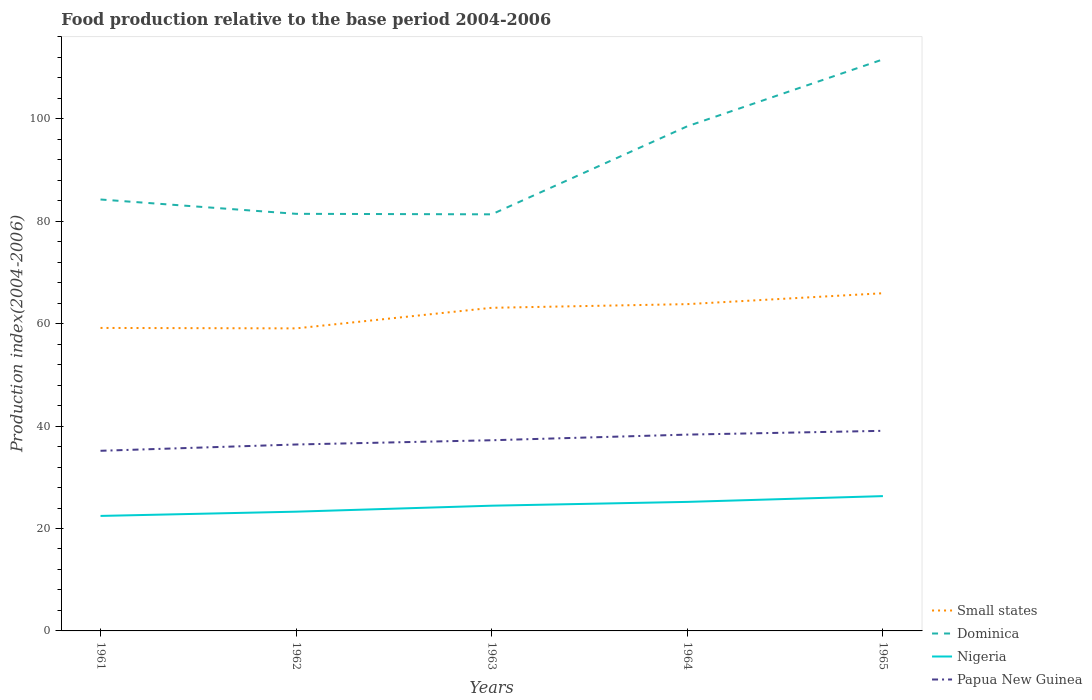Across all years, what is the maximum food production index in Papua New Guinea?
Your response must be concise. 35.18. In which year was the food production index in Small states maximum?
Give a very brief answer. 1962. What is the total food production index in Small states in the graph?
Ensure brevity in your answer.  0.09. What is the difference between the highest and the second highest food production index in Small states?
Offer a very short reply. 6.86. Is the food production index in Dominica strictly greater than the food production index in Nigeria over the years?
Ensure brevity in your answer.  No. How many lines are there?
Provide a short and direct response. 4. Are the values on the major ticks of Y-axis written in scientific E-notation?
Offer a very short reply. No. Does the graph contain grids?
Your answer should be compact. No. What is the title of the graph?
Offer a very short reply. Food production relative to the base period 2004-2006. What is the label or title of the Y-axis?
Offer a very short reply. Production index(2004-2006). What is the Production index(2004-2006) in Small states in 1961?
Offer a terse response. 59.17. What is the Production index(2004-2006) of Dominica in 1961?
Give a very brief answer. 84.26. What is the Production index(2004-2006) in Nigeria in 1961?
Your response must be concise. 22.46. What is the Production index(2004-2006) of Papua New Guinea in 1961?
Provide a succinct answer. 35.18. What is the Production index(2004-2006) in Small states in 1962?
Your answer should be very brief. 59.09. What is the Production index(2004-2006) in Dominica in 1962?
Ensure brevity in your answer.  81.46. What is the Production index(2004-2006) in Nigeria in 1962?
Keep it short and to the point. 23.29. What is the Production index(2004-2006) in Papua New Guinea in 1962?
Provide a short and direct response. 36.41. What is the Production index(2004-2006) of Small states in 1963?
Keep it short and to the point. 63.11. What is the Production index(2004-2006) of Dominica in 1963?
Provide a short and direct response. 81.36. What is the Production index(2004-2006) in Nigeria in 1963?
Your answer should be very brief. 24.46. What is the Production index(2004-2006) in Papua New Guinea in 1963?
Make the answer very short. 37.24. What is the Production index(2004-2006) in Small states in 1964?
Your response must be concise. 63.82. What is the Production index(2004-2006) in Dominica in 1964?
Your answer should be very brief. 98.56. What is the Production index(2004-2006) in Nigeria in 1964?
Your answer should be very brief. 25.2. What is the Production index(2004-2006) of Papua New Guinea in 1964?
Give a very brief answer. 38.34. What is the Production index(2004-2006) of Small states in 1965?
Provide a short and direct response. 65.95. What is the Production index(2004-2006) of Dominica in 1965?
Your response must be concise. 111.62. What is the Production index(2004-2006) in Nigeria in 1965?
Give a very brief answer. 26.33. What is the Production index(2004-2006) in Papua New Guinea in 1965?
Ensure brevity in your answer.  39.08. Across all years, what is the maximum Production index(2004-2006) in Small states?
Keep it short and to the point. 65.95. Across all years, what is the maximum Production index(2004-2006) in Dominica?
Offer a very short reply. 111.62. Across all years, what is the maximum Production index(2004-2006) of Nigeria?
Your answer should be compact. 26.33. Across all years, what is the maximum Production index(2004-2006) of Papua New Guinea?
Offer a terse response. 39.08. Across all years, what is the minimum Production index(2004-2006) of Small states?
Provide a short and direct response. 59.09. Across all years, what is the minimum Production index(2004-2006) of Dominica?
Ensure brevity in your answer.  81.36. Across all years, what is the minimum Production index(2004-2006) of Nigeria?
Provide a short and direct response. 22.46. Across all years, what is the minimum Production index(2004-2006) of Papua New Guinea?
Provide a succinct answer. 35.18. What is the total Production index(2004-2006) in Small states in the graph?
Your answer should be compact. 311.14. What is the total Production index(2004-2006) of Dominica in the graph?
Your answer should be compact. 457.26. What is the total Production index(2004-2006) in Nigeria in the graph?
Offer a terse response. 121.74. What is the total Production index(2004-2006) of Papua New Guinea in the graph?
Keep it short and to the point. 186.25. What is the difference between the Production index(2004-2006) in Small states in 1961 and that in 1962?
Keep it short and to the point. 0.09. What is the difference between the Production index(2004-2006) of Dominica in 1961 and that in 1962?
Your response must be concise. 2.8. What is the difference between the Production index(2004-2006) of Nigeria in 1961 and that in 1962?
Provide a short and direct response. -0.83. What is the difference between the Production index(2004-2006) in Papua New Guinea in 1961 and that in 1962?
Provide a short and direct response. -1.23. What is the difference between the Production index(2004-2006) of Small states in 1961 and that in 1963?
Offer a very short reply. -3.93. What is the difference between the Production index(2004-2006) in Papua New Guinea in 1961 and that in 1963?
Offer a very short reply. -2.06. What is the difference between the Production index(2004-2006) in Small states in 1961 and that in 1964?
Make the answer very short. -4.65. What is the difference between the Production index(2004-2006) in Dominica in 1961 and that in 1964?
Offer a very short reply. -14.3. What is the difference between the Production index(2004-2006) in Nigeria in 1961 and that in 1964?
Offer a very short reply. -2.74. What is the difference between the Production index(2004-2006) in Papua New Guinea in 1961 and that in 1964?
Your answer should be very brief. -3.16. What is the difference between the Production index(2004-2006) of Small states in 1961 and that in 1965?
Your answer should be very brief. -6.78. What is the difference between the Production index(2004-2006) in Dominica in 1961 and that in 1965?
Keep it short and to the point. -27.36. What is the difference between the Production index(2004-2006) in Nigeria in 1961 and that in 1965?
Ensure brevity in your answer.  -3.87. What is the difference between the Production index(2004-2006) of Small states in 1962 and that in 1963?
Offer a very short reply. -4.02. What is the difference between the Production index(2004-2006) in Dominica in 1962 and that in 1963?
Provide a succinct answer. 0.1. What is the difference between the Production index(2004-2006) of Nigeria in 1962 and that in 1963?
Provide a succinct answer. -1.17. What is the difference between the Production index(2004-2006) of Papua New Guinea in 1962 and that in 1963?
Ensure brevity in your answer.  -0.83. What is the difference between the Production index(2004-2006) in Small states in 1962 and that in 1964?
Your response must be concise. -4.73. What is the difference between the Production index(2004-2006) in Dominica in 1962 and that in 1964?
Give a very brief answer. -17.1. What is the difference between the Production index(2004-2006) in Nigeria in 1962 and that in 1964?
Provide a succinct answer. -1.91. What is the difference between the Production index(2004-2006) of Papua New Guinea in 1962 and that in 1964?
Provide a succinct answer. -1.93. What is the difference between the Production index(2004-2006) of Small states in 1962 and that in 1965?
Your answer should be compact. -6.86. What is the difference between the Production index(2004-2006) in Dominica in 1962 and that in 1965?
Give a very brief answer. -30.16. What is the difference between the Production index(2004-2006) of Nigeria in 1962 and that in 1965?
Offer a terse response. -3.04. What is the difference between the Production index(2004-2006) of Papua New Guinea in 1962 and that in 1965?
Offer a terse response. -2.67. What is the difference between the Production index(2004-2006) of Small states in 1963 and that in 1964?
Provide a succinct answer. -0.72. What is the difference between the Production index(2004-2006) in Dominica in 1963 and that in 1964?
Your response must be concise. -17.2. What is the difference between the Production index(2004-2006) of Nigeria in 1963 and that in 1964?
Ensure brevity in your answer.  -0.74. What is the difference between the Production index(2004-2006) of Small states in 1963 and that in 1965?
Your answer should be very brief. -2.84. What is the difference between the Production index(2004-2006) in Dominica in 1963 and that in 1965?
Your answer should be compact. -30.26. What is the difference between the Production index(2004-2006) in Nigeria in 1963 and that in 1965?
Make the answer very short. -1.87. What is the difference between the Production index(2004-2006) in Papua New Guinea in 1963 and that in 1965?
Provide a succinct answer. -1.84. What is the difference between the Production index(2004-2006) in Small states in 1964 and that in 1965?
Your answer should be compact. -2.13. What is the difference between the Production index(2004-2006) of Dominica in 1964 and that in 1965?
Offer a very short reply. -13.06. What is the difference between the Production index(2004-2006) in Nigeria in 1964 and that in 1965?
Offer a terse response. -1.13. What is the difference between the Production index(2004-2006) in Papua New Guinea in 1964 and that in 1965?
Give a very brief answer. -0.74. What is the difference between the Production index(2004-2006) of Small states in 1961 and the Production index(2004-2006) of Dominica in 1962?
Your answer should be very brief. -22.29. What is the difference between the Production index(2004-2006) of Small states in 1961 and the Production index(2004-2006) of Nigeria in 1962?
Provide a succinct answer. 35.88. What is the difference between the Production index(2004-2006) in Small states in 1961 and the Production index(2004-2006) in Papua New Guinea in 1962?
Offer a very short reply. 22.76. What is the difference between the Production index(2004-2006) of Dominica in 1961 and the Production index(2004-2006) of Nigeria in 1962?
Your answer should be very brief. 60.97. What is the difference between the Production index(2004-2006) in Dominica in 1961 and the Production index(2004-2006) in Papua New Guinea in 1962?
Your response must be concise. 47.85. What is the difference between the Production index(2004-2006) of Nigeria in 1961 and the Production index(2004-2006) of Papua New Guinea in 1962?
Your answer should be compact. -13.95. What is the difference between the Production index(2004-2006) of Small states in 1961 and the Production index(2004-2006) of Dominica in 1963?
Give a very brief answer. -22.19. What is the difference between the Production index(2004-2006) in Small states in 1961 and the Production index(2004-2006) in Nigeria in 1963?
Give a very brief answer. 34.71. What is the difference between the Production index(2004-2006) in Small states in 1961 and the Production index(2004-2006) in Papua New Guinea in 1963?
Your answer should be compact. 21.93. What is the difference between the Production index(2004-2006) of Dominica in 1961 and the Production index(2004-2006) of Nigeria in 1963?
Offer a terse response. 59.8. What is the difference between the Production index(2004-2006) in Dominica in 1961 and the Production index(2004-2006) in Papua New Guinea in 1963?
Your answer should be very brief. 47.02. What is the difference between the Production index(2004-2006) in Nigeria in 1961 and the Production index(2004-2006) in Papua New Guinea in 1963?
Provide a succinct answer. -14.78. What is the difference between the Production index(2004-2006) of Small states in 1961 and the Production index(2004-2006) of Dominica in 1964?
Make the answer very short. -39.39. What is the difference between the Production index(2004-2006) of Small states in 1961 and the Production index(2004-2006) of Nigeria in 1964?
Keep it short and to the point. 33.97. What is the difference between the Production index(2004-2006) in Small states in 1961 and the Production index(2004-2006) in Papua New Guinea in 1964?
Your answer should be compact. 20.83. What is the difference between the Production index(2004-2006) of Dominica in 1961 and the Production index(2004-2006) of Nigeria in 1964?
Give a very brief answer. 59.06. What is the difference between the Production index(2004-2006) of Dominica in 1961 and the Production index(2004-2006) of Papua New Guinea in 1964?
Offer a terse response. 45.92. What is the difference between the Production index(2004-2006) in Nigeria in 1961 and the Production index(2004-2006) in Papua New Guinea in 1964?
Your answer should be compact. -15.88. What is the difference between the Production index(2004-2006) of Small states in 1961 and the Production index(2004-2006) of Dominica in 1965?
Keep it short and to the point. -52.45. What is the difference between the Production index(2004-2006) of Small states in 1961 and the Production index(2004-2006) of Nigeria in 1965?
Provide a succinct answer. 32.84. What is the difference between the Production index(2004-2006) in Small states in 1961 and the Production index(2004-2006) in Papua New Guinea in 1965?
Offer a very short reply. 20.09. What is the difference between the Production index(2004-2006) in Dominica in 1961 and the Production index(2004-2006) in Nigeria in 1965?
Ensure brevity in your answer.  57.93. What is the difference between the Production index(2004-2006) in Dominica in 1961 and the Production index(2004-2006) in Papua New Guinea in 1965?
Offer a terse response. 45.18. What is the difference between the Production index(2004-2006) in Nigeria in 1961 and the Production index(2004-2006) in Papua New Guinea in 1965?
Ensure brevity in your answer.  -16.62. What is the difference between the Production index(2004-2006) of Small states in 1962 and the Production index(2004-2006) of Dominica in 1963?
Keep it short and to the point. -22.27. What is the difference between the Production index(2004-2006) of Small states in 1962 and the Production index(2004-2006) of Nigeria in 1963?
Offer a terse response. 34.63. What is the difference between the Production index(2004-2006) in Small states in 1962 and the Production index(2004-2006) in Papua New Guinea in 1963?
Your response must be concise. 21.85. What is the difference between the Production index(2004-2006) of Dominica in 1962 and the Production index(2004-2006) of Nigeria in 1963?
Your answer should be very brief. 57. What is the difference between the Production index(2004-2006) in Dominica in 1962 and the Production index(2004-2006) in Papua New Guinea in 1963?
Your response must be concise. 44.22. What is the difference between the Production index(2004-2006) of Nigeria in 1962 and the Production index(2004-2006) of Papua New Guinea in 1963?
Provide a short and direct response. -13.95. What is the difference between the Production index(2004-2006) of Small states in 1962 and the Production index(2004-2006) of Dominica in 1964?
Make the answer very short. -39.47. What is the difference between the Production index(2004-2006) of Small states in 1962 and the Production index(2004-2006) of Nigeria in 1964?
Your response must be concise. 33.89. What is the difference between the Production index(2004-2006) in Small states in 1962 and the Production index(2004-2006) in Papua New Guinea in 1964?
Your response must be concise. 20.75. What is the difference between the Production index(2004-2006) in Dominica in 1962 and the Production index(2004-2006) in Nigeria in 1964?
Make the answer very short. 56.26. What is the difference between the Production index(2004-2006) of Dominica in 1962 and the Production index(2004-2006) of Papua New Guinea in 1964?
Give a very brief answer. 43.12. What is the difference between the Production index(2004-2006) in Nigeria in 1962 and the Production index(2004-2006) in Papua New Guinea in 1964?
Provide a succinct answer. -15.05. What is the difference between the Production index(2004-2006) in Small states in 1962 and the Production index(2004-2006) in Dominica in 1965?
Give a very brief answer. -52.53. What is the difference between the Production index(2004-2006) in Small states in 1962 and the Production index(2004-2006) in Nigeria in 1965?
Your response must be concise. 32.76. What is the difference between the Production index(2004-2006) in Small states in 1962 and the Production index(2004-2006) in Papua New Guinea in 1965?
Provide a short and direct response. 20.01. What is the difference between the Production index(2004-2006) in Dominica in 1962 and the Production index(2004-2006) in Nigeria in 1965?
Ensure brevity in your answer.  55.13. What is the difference between the Production index(2004-2006) in Dominica in 1962 and the Production index(2004-2006) in Papua New Guinea in 1965?
Ensure brevity in your answer.  42.38. What is the difference between the Production index(2004-2006) in Nigeria in 1962 and the Production index(2004-2006) in Papua New Guinea in 1965?
Your answer should be very brief. -15.79. What is the difference between the Production index(2004-2006) in Small states in 1963 and the Production index(2004-2006) in Dominica in 1964?
Offer a very short reply. -35.45. What is the difference between the Production index(2004-2006) in Small states in 1963 and the Production index(2004-2006) in Nigeria in 1964?
Ensure brevity in your answer.  37.91. What is the difference between the Production index(2004-2006) in Small states in 1963 and the Production index(2004-2006) in Papua New Guinea in 1964?
Your response must be concise. 24.77. What is the difference between the Production index(2004-2006) in Dominica in 1963 and the Production index(2004-2006) in Nigeria in 1964?
Ensure brevity in your answer.  56.16. What is the difference between the Production index(2004-2006) of Dominica in 1963 and the Production index(2004-2006) of Papua New Guinea in 1964?
Make the answer very short. 43.02. What is the difference between the Production index(2004-2006) in Nigeria in 1963 and the Production index(2004-2006) in Papua New Guinea in 1964?
Your answer should be very brief. -13.88. What is the difference between the Production index(2004-2006) in Small states in 1963 and the Production index(2004-2006) in Dominica in 1965?
Your answer should be very brief. -48.51. What is the difference between the Production index(2004-2006) in Small states in 1963 and the Production index(2004-2006) in Nigeria in 1965?
Provide a short and direct response. 36.78. What is the difference between the Production index(2004-2006) of Small states in 1963 and the Production index(2004-2006) of Papua New Guinea in 1965?
Your answer should be very brief. 24.03. What is the difference between the Production index(2004-2006) in Dominica in 1963 and the Production index(2004-2006) in Nigeria in 1965?
Offer a terse response. 55.03. What is the difference between the Production index(2004-2006) in Dominica in 1963 and the Production index(2004-2006) in Papua New Guinea in 1965?
Ensure brevity in your answer.  42.28. What is the difference between the Production index(2004-2006) in Nigeria in 1963 and the Production index(2004-2006) in Papua New Guinea in 1965?
Keep it short and to the point. -14.62. What is the difference between the Production index(2004-2006) in Small states in 1964 and the Production index(2004-2006) in Dominica in 1965?
Ensure brevity in your answer.  -47.8. What is the difference between the Production index(2004-2006) in Small states in 1964 and the Production index(2004-2006) in Nigeria in 1965?
Your answer should be very brief. 37.49. What is the difference between the Production index(2004-2006) in Small states in 1964 and the Production index(2004-2006) in Papua New Guinea in 1965?
Keep it short and to the point. 24.74. What is the difference between the Production index(2004-2006) of Dominica in 1964 and the Production index(2004-2006) of Nigeria in 1965?
Your answer should be very brief. 72.23. What is the difference between the Production index(2004-2006) of Dominica in 1964 and the Production index(2004-2006) of Papua New Guinea in 1965?
Keep it short and to the point. 59.48. What is the difference between the Production index(2004-2006) in Nigeria in 1964 and the Production index(2004-2006) in Papua New Guinea in 1965?
Provide a short and direct response. -13.88. What is the average Production index(2004-2006) of Small states per year?
Keep it short and to the point. 62.23. What is the average Production index(2004-2006) in Dominica per year?
Give a very brief answer. 91.45. What is the average Production index(2004-2006) in Nigeria per year?
Offer a terse response. 24.35. What is the average Production index(2004-2006) of Papua New Guinea per year?
Give a very brief answer. 37.25. In the year 1961, what is the difference between the Production index(2004-2006) of Small states and Production index(2004-2006) of Dominica?
Your answer should be compact. -25.09. In the year 1961, what is the difference between the Production index(2004-2006) in Small states and Production index(2004-2006) in Nigeria?
Make the answer very short. 36.71. In the year 1961, what is the difference between the Production index(2004-2006) in Small states and Production index(2004-2006) in Papua New Guinea?
Your answer should be compact. 23.99. In the year 1961, what is the difference between the Production index(2004-2006) of Dominica and Production index(2004-2006) of Nigeria?
Ensure brevity in your answer.  61.8. In the year 1961, what is the difference between the Production index(2004-2006) of Dominica and Production index(2004-2006) of Papua New Guinea?
Provide a succinct answer. 49.08. In the year 1961, what is the difference between the Production index(2004-2006) in Nigeria and Production index(2004-2006) in Papua New Guinea?
Provide a short and direct response. -12.72. In the year 1962, what is the difference between the Production index(2004-2006) of Small states and Production index(2004-2006) of Dominica?
Give a very brief answer. -22.37. In the year 1962, what is the difference between the Production index(2004-2006) of Small states and Production index(2004-2006) of Nigeria?
Give a very brief answer. 35.8. In the year 1962, what is the difference between the Production index(2004-2006) in Small states and Production index(2004-2006) in Papua New Guinea?
Give a very brief answer. 22.68. In the year 1962, what is the difference between the Production index(2004-2006) in Dominica and Production index(2004-2006) in Nigeria?
Provide a succinct answer. 58.17. In the year 1962, what is the difference between the Production index(2004-2006) of Dominica and Production index(2004-2006) of Papua New Guinea?
Your answer should be very brief. 45.05. In the year 1962, what is the difference between the Production index(2004-2006) of Nigeria and Production index(2004-2006) of Papua New Guinea?
Ensure brevity in your answer.  -13.12. In the year 1963, what is the difference between the Production index(2004-2006) of Small states and Production index(2004-2006) of Dominica?
Offer a terse response. -18.25. In the year 1963, what is the difference between the Production index(2004-2006) in Small states and Production index(2004-2006) in Nigeria?
Offer a terse response. 38.65. In the year 1963, what is the difference between the Production index(2004-2006) of Small states and Production index(2004-2006) of Papua New Guinea?
Give a very brief answer. 25.87. In the year 1963, what is the difference between the Production index(2004-2006) of Dominica and Production index(2004-2006) of Nigeria?
Your answer should be very brief. 56.9. In the year 1963, what is the difference between the Production index(2004-2006) in Dominica and Production index(2004-2006) in Papua New Guinea?
Provide a succinct answer. 44.12. In the year 1963, what is the difference between the Production index(2004-2006) in Nigeria and Production index(2004-2006) in Papua New Guinea?
Make the answer very short. -12.78. In the year 1964, what is the difference between the Production index(2004-2006) of Small states and Production index(2004-2006) of Dominica?
Offer a very short reply. -34.74. In the year 1964, what is the difference between the Production index(2004-2006) of Small states and Production index(2004-2006) of Nigeria?
Provide a short and direct response. 38.62. In the year 1964, what is the difference between the Production index(2004-2006) of Small states and Production index(2004-2006) of Papua New Guinea?
Provide a short and direct response. 25.48. In the year 1964, what is the difference between the Production index(2004-2006) of Dominica and Production index(2004-2006) of Nigeria?
Provide a short and direct response. 73.36. In the year 1964, what is the difference between the Production index(2004-2006) of Dominica and Production index(2004-2006) of Papua New Guinea?
Your answer should be very brief. 60.22. In the year 1964, what is the difference between the Production index(2004-2006) in Nigeria and Production index(2004-2006) in Papua New Guinea?
Ensure brevity in your answer.  -13.14. In the year 1965, what is the difference between the Production index(2004-2006) in Small states and Production index(2004-2006) in Dominica?
Provide a short and direct response. -45.67. In the year 1965, what is the difference between the Production index(2004-2006) of Small states and Production index(2004-2006) of Nigeria?
Your answer should be very brief. 39.62. In the year 1965, what is the difference between the Production index(2004-2006) in Small states and Production index(2004-2006) in Papua New Guinea?
Keep it short and to the point. 26.87. In the year 1965, what is the difference between the Production index(2004-2006) of Dominica and Production index(2004-2006) of Nigeria?
Ensure brevity in your answer.  85.29. In the year 1965, what is the difference between the Production index(2004-2006) in Dominica and Production index(2004-2006) in Papua New Guinea?
Offer a very short reply. 72.54. In the year 1965, what is the difference between the Production index(2004-2006) in Nigeria and Production index(2004-2006) in Papua New Guinea?
Offer a very short reply. -12.75. What is the ratio of the Production index(2004-2006) of Small states in 1961 to that in 1962?
Keep it short and to the point. 1. What is the ratio of the Production index(2004-2006) of Dominica in 1961 to that in 1962?
Offer a very short reply. 1.03. What is the ratio of the Production index(2004-2006) in Nigeria in 1961 to that in 1962?
Keep it short and to the point. 0.96. What is the ratio of the Production index(2004-2006) in Papua New Guinea in 1961 to that in 1962?
Provide a short and direct response. 0.97. What is the ratio of the Production index(2004-2006) in Small states in 1961 to that in 1963?
Give a very brief answer. 0.94. What is the ratio of the Production index(2004-2006) in Dominica in 1961 to that in 1963?
Your answer should be very brief. 1.04. What is the ratio of the Production index(2004-2006) of Nigeria in 1961 to that in 1963?
Offer a terse response. 0.92. What is the ratio of the Production index(2004-2006) of Papua New Guinea in 1961 to that in 1963?
Offer a terse response. 0.94. What is the ratio of the Production index(2004-2006) in Small states in 1961 to that in 1964?
Keep it short and to the point. 0.93. What is the ratio of the Production index(2004-2006) in Dominica in 1961 to that in 1964?
Keep it short and to the point. 0.85. What is the ratio of the Production index(2004-2006) of Nigeria in 1961 to that in 1964?
Your response must be concise. 0.89. What is the ratio of the Production index(2004-2006) of Papua New Guinea in 1961 to that in 1964?
Your response must be concise. 0.92. What is the ratio of the Production index(2004-2006) in Small states in 1961 to that in 1965?
Give a very brief answer. 0.9. What is the ratio of the Production index(2004-2006) of Dominica in 1961 to that in 1965?
Provide a short and direct response. 0.75. What is the ratio of the Production index(2004-2006) in Nigeria in 1961 to that in 1965?
Offer a very short reply. 0.85. What is the ratio of the Production index(2004-2006) of Papua New Guinea in 1961 to that in 1965?
Offer a very short reply. 0.9. What is the ratio of the Production index(2004-2006) of Small states in 1962 to that in 1963?
Offer a very short reply. 0.94. What is the ratio of the Production index(2004-2006) of Dominica in 1962 to that in 1963?
Make the answer very short. 1. What is the ratio of the Production index(2004-2006) of Nigeria in 1962 to that in 1963?
Your answer should be very brief. 0.95. What is the ratio of the Production index(2004-2006) of Papua New Guinea in 1962 to that in 1963?
Give a very brief answer. 0.98. What is the ratio of the Production index(2004-2006) of Small states in 1962 to that in 1964?
Ensure brevity in your answer.  0.93. What is the ratio of the Production index(2004-2006) of Dominica in 1962 to that in 1964?
Offer a terse response. 0.83. What is the ratio of the Production index(2004-2006) of Nigeria in 1962 to that in 1964?
Keep it short and to the point. 0.92. What is the ratio of the Production index(2004-2006) of Papua New Guinea in 1962 to that in 1964?
Give a very brief answer. 0.95. What is the ratio of the Production index(2004-2006) of Small states in 1962 to that in 1965?
Make the answer very short. 0.9. What is the ratio of the Production index(2004-2006) in Dominica in 1962 to that in 1965?
Provide a short and direct response. 0.73. What is the ratio of the Production index(2004-2006) of Nigeria in 1962 to that in 1965?
Offer a very short reply. 0.88. What is the ratio of the Production index(2004-2006) in Papua New Guinea in 1962 to that in 1965?
Make the answer very short. 0.93. What is the ratio of the Production index(2004-2006) in Small states in 1963 to that in 1964?
Your response must be concise. 0.99. What is the ratio of the Production index(2004-2006) of Dominica in 1963 to that in 1964?
Your response must be concise. 0.83. What is the ratio of the Production index(2004-2006) in Nigeria in 1963 to that in 1964?
Provide a succinct answer. 0.97. What is the ratio of the Production index(2004-2006) of Papua New Guinea in 1963 to that in 1964?
Offer a terse response. 0.97. What is the ratio of the Production index(2004-2006) of Small states in 1963 to that in 1965?
Offer a very short reply. 0.96. What is the ratio of the Production index(2004-2006) of Dominica in 1963 to that in 1965?
Make the answer very short. 0.73. What is the ratio of the Production index(2004-2006) of Nigeria in 1963 to that in 1965?
Make the answer very short. 0.93. What is the ratio of the Production index(2004-2006) in Papua New Guinea in 1963 to that in 1965?
Your answer should be compact. 0.95. What is the ratio of the Production index(2004-2006) of Small states in 1964 to that in 1965?
Provide a succinct answer. 0.97. What is the ratio of the Production index(2004-2006) of Dominica in 1964 to that in 1965?
Ensure brevity in your answer.  0.88. What is the ratio of the Production index(2004-2006) of Nigeria in 1964 to that in 1965?
Provide a succinct answer. 0.96. What is the ratio of the Production index(2004-2006) in Papua New Guinea in 1964 to that in 1965?
Give a very brief answer. 0.98. What is the difference between the highest and the second highest Production index(2004-2006) in Small states?
Give a very brief answer. 2.13. What is the difference between the highest and the second highest Production index(2004-2006) in Dominica?
Your answer should be compact. 13.06. What is the difference between the highest and the second highest Production index(2004-2006) in Nigeria?
Offer a terse response. 1.13. What is the difference between the highest and the second highest Production index(2004-2006) of Papua New Guinea?
Your answer should be compact. 0.74. What is the difference between the highest and the lowest Production index(2004-2006) of Small states?
Offer a terse response. 6.86. What is the difference between the highest and the lowest Production index(2004-2006) of Dominica?
Give a very brief answer. 30.26. What is the difference between the highest and the lowest Production index(2004-2006) of Nigeria?
Your response must be concise. 3.87. What is the difference between the highest and the lowest Production index(2004-2006) of Papua New Guinea?
Your answer should be compact. 3.9. 